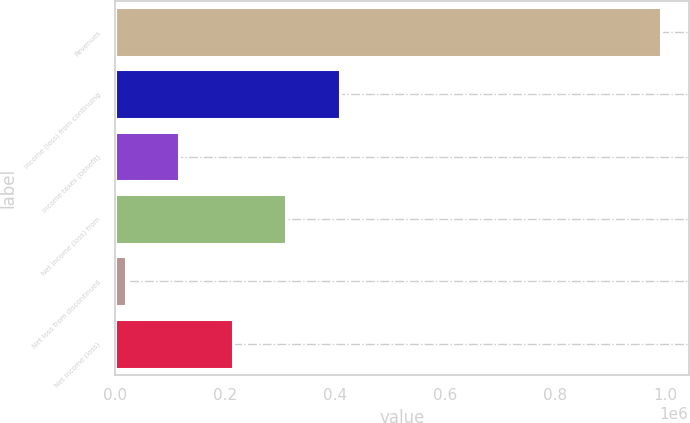Convert chart. <chart><loc_0><loc_0><loc_500><loc_500><bar_chart><fcel>Revenues<fcel>Income (loss) from continuing<fcel>Income taxes (benefit)<fcel>Net income (loss) from<fcel>Net loss from discontinued<fcel>Net income (loss)<nl><fcel>993446<fcel>409059<fcel>116865<fcel>311661<fcel>19467<fcel>214263<nl></chart> 